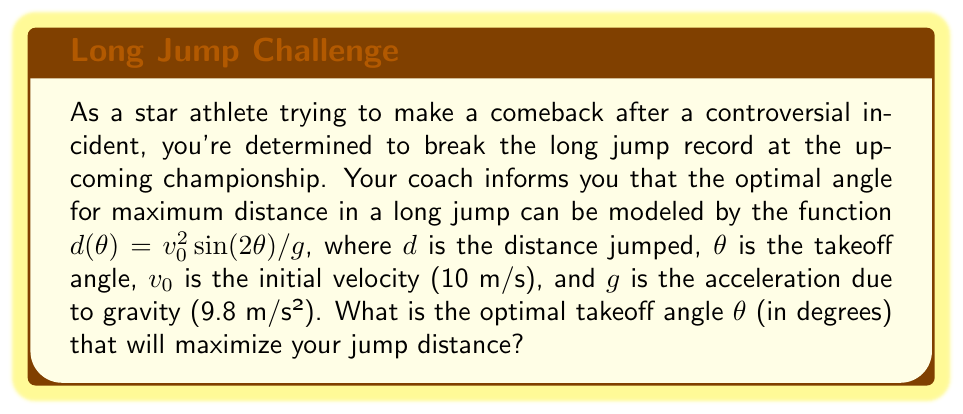Help me with this question. To find the optimal takeoff angle, we need to maximize the function $d(\theta)$. Let's approach this step-by-step:

1) The given function is:
   $$d(\theta) = \frac{v_0^2 \sin(2\theta)}{g}$$

2) To find the maximum, we need to find where the derivative of this function equals zero:
   $$\frac{d}{d\theta}(d(\theta)) = \frac{v_0^2}{g} \cdot 2\cos(2\theta) = 0$$

3) Solving this equation:
   $$2\cos(2\theta) = 0$$
   $$\cos(2\theta) = 0$$

4) We know that cosine equals zero when its argument is $\frac{\pi}{2}$ or $\frac{3\pi}{2}$ radians. So:
   $$2\theta = \frac{\pi}{2}$$ or $$2\theta = \frac{3\pi}{2}$$

5) Solving for $\theta$:
   $$\theta = \frac{\pi}{4}$$ or $$\theta = \frac{3\pi}{4}$$

6) The second solution ($\frac{3\pi}{4}$) would result in a negative jump distance, so we can discard it.

7) Therefore, the optimal angle is $\frac{\pi}{4}$ radians.

8) Converting to degrees:
   $$\theta = \frac{\pi}{4} \cdot \frac{180°}{\pi} = 45°$$

Thus, the optimal takeoff angle for maximum distance in the long jump is 45°.
Answer: 45° 